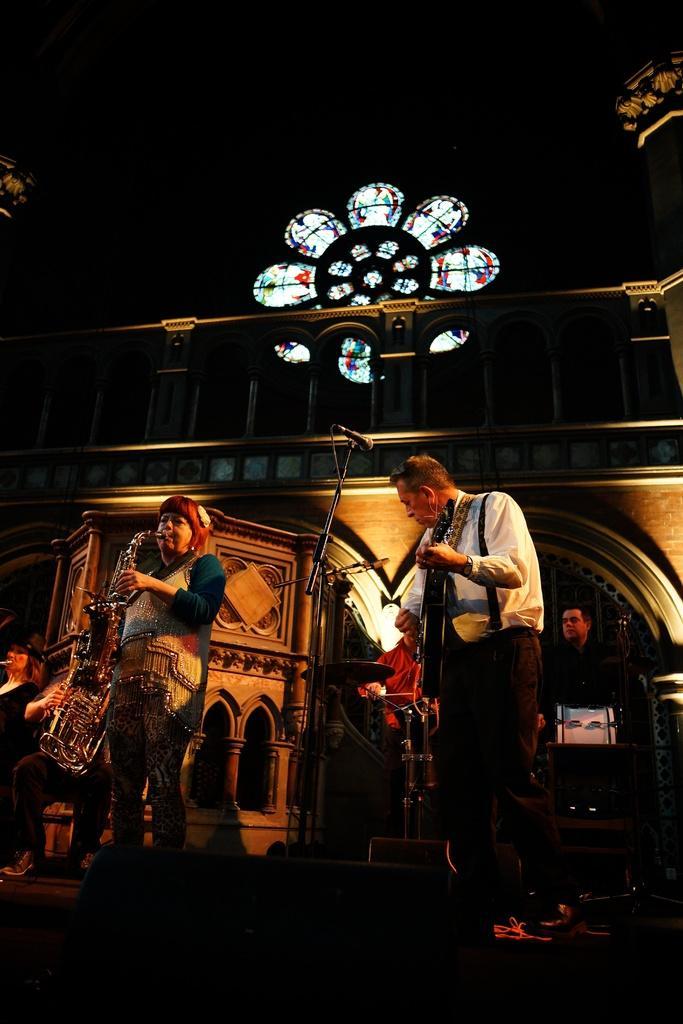In one or two sentences, can you explain what this image depicts? Background portion of the picture is completely dark. We can see the painting on the glass window. In this picture we can see the objects, people playing musical instruments and we can see the designed wall, railing. Partial part of the pillars are visible. Bottom portion of the picture is dark. 